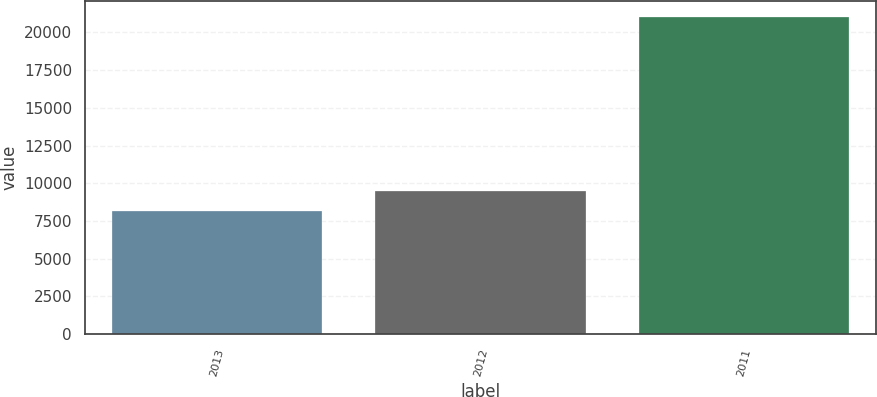<chart> <loc_0><loc_0><loc_500><loc_500><bar_chart><fcel>2013<fcel>2012<fcel>2011<nl><fcel>8178<fcel>9464.1<fcel>21039<nl></chart> 